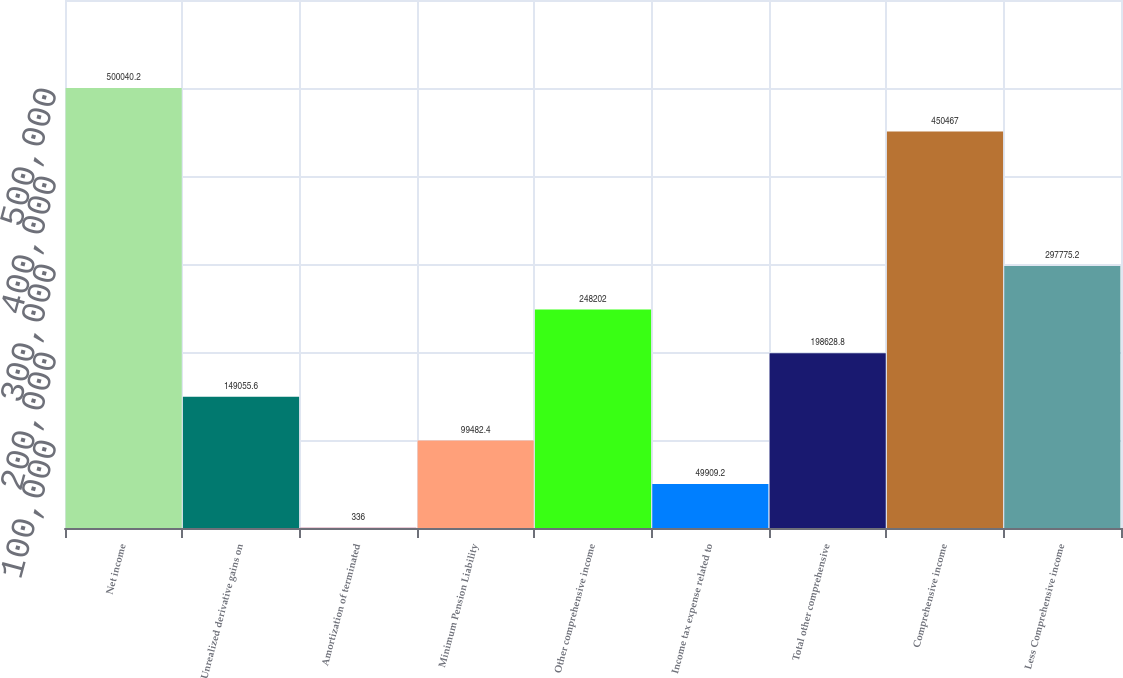<chart> <loc_0><loc_0><loc_500><loc_500><bar_chart><fcel>Net income<fcel>Unrealized derivative gains on<fcel>Amortization of terminated<fcel>Minimum Pension Liability<fcel>Other comprehensive income<fcel>Income tax expense related to<fcel>Total other comprehensive<fcel>Comprehensive income<fcel>Less Comprehensive income<nl><fcel>500040<fcel>149056<fcel>336<fcel>99482.4<fcel>248202<fcel>49909.2<fcel>198629<fcel>450467<fcel>297775<nl></chart> 